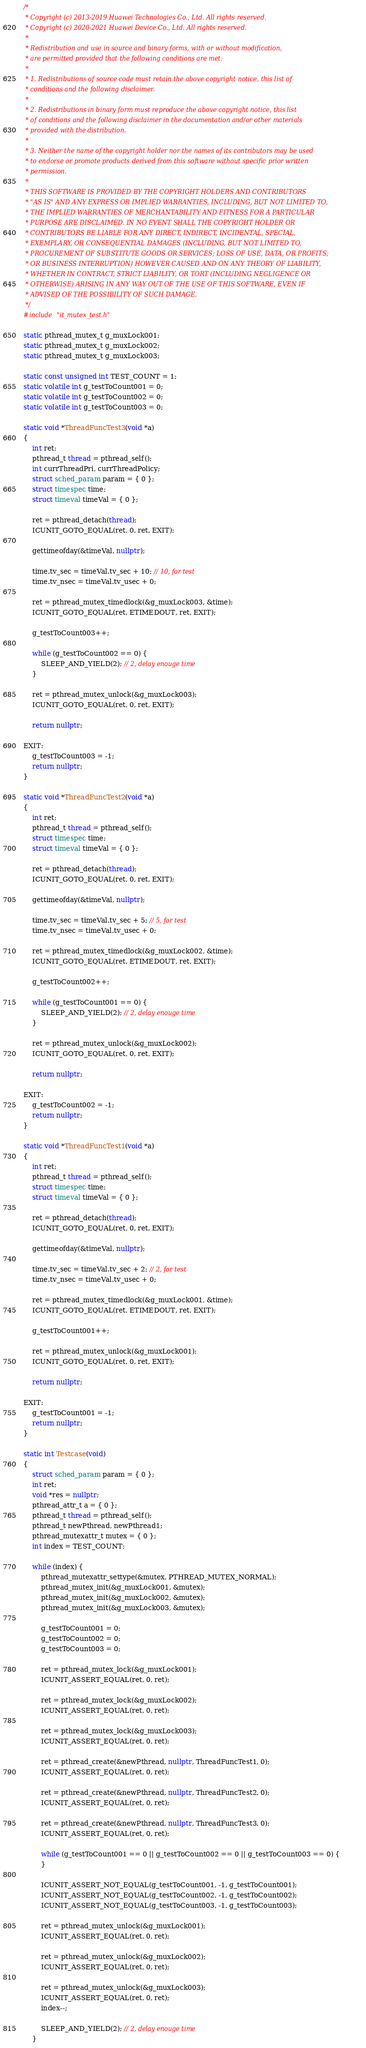Convert code to text. <code><loc_0><loc_0><loc_500><loc_500><_C++_>/*
 * Copyright (c) 2013-2019 Huawei Technologies Co., Ltd. All rights reserved.
 * Copyright (c) 2020-2021 Huawei Device Co., Ltd. All rights reserved.
 *
 * Redistribution and use in source and binary forms, with or without modification,
 * are permitted provided that the following conditions are met:
 *
 * 1. Redistributions of source code must retain the above copyright notice, this list of
 * conditions and the following disclaimer.
 *
 * 2. Redistributions in binary form must reproduce the above copyright notice, this list
 * of conditions and the following disclaimer in the documentation and/or other materials
 * provided with the distribution.
 *
 * 3. Neither the name of the copyright holder nor the names of its contributors may be used
 * to endorse or promote products derived from this software without specific prior written
 * permission.
 *
 * THIS SOFTWARE IS PROVIDED BY THE COPYRIGHT HOLDERS AND CONTRIBUTORS
 * "AS IS" AND ANY EXPRESS OR IMPLIED WARRANTIES, INCLUDING, BUT NOT LIMITED TO,
 * THE IMPLIED WARRANTIES OF MERCHANTABILITY AND FITNESS FOR A PARTICULAR
 * PURPOSE ARE DISCLAIMED. IN NO EVENT SHALL THE COPYRIGHT HOLDER OR
 * CONTRIBUTORS BE LIABLE FOR ANY DIRECT, INDIRECT, INCIDENTAL, SPECIAL,
 * EXEMPLARY, OR CONSEQUENTIAL DAMAGES (INCLUDING, BUT NOT LIMITED TO,
 * PROCUREMENT OF SUBSTITUTE GOODS OR SERVICES; LOSS OF USE, DATA, OR PROFITS;
 * OR BUSINESS INTERRUPTION) HOWEVER CAUSED AND ON ANY THEORY OF LIABILITY,
 * WHETHER IN CONTRACT, STRICT LIABILITY, OR TORT (INCLUDING NEGLIGENCE OR
 * OTHERWISE) ARISING IN ANY WAY OUT OF THE USE OF THIS SOFTWARE, EVEN IF
 * ADVISED OF THE POSSIBILITY OF SUCH DAMAGE.
 */
#include "it_mutex_test.h"

static pthread_mutex_t g_muxLock001;
static pthread_mutex_t g_muxLock002;
static pthread_mutex_t g_muxLock003;

static const unsigned int TEST_COUNT = 1;
static volatile int g_testToCount001 = 0;
static volatile int g_testToCount002 = 0;
static volatile int g_testToCount003 = 0;

static void *ThreadFuncTest3(void *a)
{
    int ret;
    pthread_t thread = pthread_self();
    int currThreadPri, currThreadPolicy;
    struct sched_param param = { 0 };
    struct timespec time;
    struct timeval timeVal = { 0 };

    ret = pthread_detach(thread);
    ICUNIT_GOTO_EQUAL(ret, 0, ret, EXIT);

    gettimeofday(&timeVal, nullptr);

    time.tv_sec = timeVal.tv_sec + 10; // 10, for test
    time.tv_nsec = timeVal.tv_usec + 0;

    ret = pthread_mutex_timedlock(&g_muxLock003, &time);
    ICUNIT_GOTO_EQUAL(ret, ETIMEDOUT, ret, EXIT);

    g_testToCount003++;

    while (g_testToCount002 == 0) {
        SLEEP_AND_YIELD(2); // 2, delay enouge time
    }

    ret = pthread_mutex_unlock(&g_muxLock003);
    ICUNIT_GOTO_EQUAL(ret, 0, ret, EXIT);

    return nullptr;

EXIT:
    g_testToCount003 = -1;
    return nullptr;
}

static void *ThreadFuncTest2(void *a)
{
    int ret;
    pthread_t thread = pthread_self();
    struct timespec time;
    struct timeval timeVal = { 0 };

    ret = pthread_detach(thread);
    ICUNIT_GOTO_EQUAL(ret, 0, ret, EXIT);

    gettimeofday(&timeVal, nullptr);

    time.tv_sec = timeVal.tv_sec + 5; // 5, for test
    time.tv_nsec = timeVal.tv_usec + 0;

    ret = pthread_mutex_timedlock(&g_muxLock002, &time);
    ICUNIT_GOTO_EQUAL(ret, ETIMEDOUT, ret, EXIT);

    g_testToCount002++;

    while (g_testToCount001 == 0) {
        SLEEP_AND_YIELD(2); // 2, delay enouge time
    }

    ret = pthread_mutex_unlock(&g_muxLock002);
    ICUNIT_GOTO_EQUAL(ret, 0, ret, EXIT);

    return nullptr;

EXIT:
    g_testToCount002 = -1;
    return nullptr;
}

static void *ThreadFuncTest1(void *a)
{
    int ret;
    pthread_t thread = pthread_self();
    struct timespec time;
    struct timeval timeVal = { 0 };

    ret = pthread_detach(thread);
    ICUNIT_GOTO_EQUAL(ret, 0, ret, EXIT);

    gettimeofday(&timeVal, nullptr);

    time.tv_sec = timeVal.tv_sec + 2; // 2, for test
    time.tv_nsec = timeVal.tv_usec + 0;

    ret = pthread_mutex_timedlock(&g_muxLock001, &time);
    ICUNIT_GOTO_EQUAL(ret, ETIMEDOUT, ret, EXIT);

    g_testToCount001++;

    ret = pthread_mutex_unlock(&g_muxLock001);
    ICUNIT_GOTO_EQUAL(ret, 0, ret, EXIT);

    return nullptr;

EXIT:
    g_testToCount001 = -1;
    return nullptr;
}

static int Testcase(void)
{
    struct sched_param param = { 0 };
    int ret;
    void *res = nullptr;
    pthread_attr_t a = { 0 };
    pthread_t thread = pthread_self();
    pthread_t newPthread, newPthread1;
    pthread_mutexattr_t mutex = { 0 };
    int index = TEST_COUNT;

    while (index) {
        pthread_mutexattr_settype(&mutex, PTHREAD_MUTEX_NORMAL);
        pthread_mutex_init(&g_muxLock001, &mutex);
        pthread_mutex_init(&g_muxLock002, &mutex);
        pthread_mutex_init(&g_muxLock003, &mutex);

        g_testToCount001 = 0;
        g_testToCount002 = 0;
        g_testToCount003 = 0;

        ret = pthread_mutex_lock(&g_muxLock001);
        ICUNIT_ASSERT_EQUAL(ret, 0, ret);

        ret = pthread_mutex_lock(&g_muxLock002);
        ICUNIT_ASSERT_EQUAL(ret, 0, ret);

        ret = pthread_mutex_lock(&g_muxLock003);
        ICUNIT_ASSERT_EQUAL(ret, 0, ret);

        ret = pthread_create(&newPthread, nullptr, ThreadFuncTest1, 0);
        ICUNIT_ASSERT_EQUAL(ret, 0, ret);

        ret = pthread_create(&newPthread, nullptr, ThreadFuncTest2, 0);
        ICUNIT_ASSERT_EQUAL(ret, 0, ret);

        ret = pthread_create(&newPthread, nullptr, ThreadFuncTest3, 0);
        ICUNIT_ASSERT_EQUAL(ret, 0, ret);

        while (g_testToCount001 == 0 || g_testToCount002 == 0 || g_testToCount003 == 0) {
        }

        ICUNIT_ASSERT_NOT_EQUAL(g_testToCount001, -1, g_testToCount001);
        ICUNIT_ASSERT_NOT_EQUAL(g_testToCount002, -1, g_testToCount002);
        ICUNIT_ASSERT_NOT_EQUAL(g_testToCount003, -1, g_testToCount003);

        ret = pthread_mutex_unlock(&g_muxLock001);
        ICUNIT_ASSERT_EQUAL(ret, 0, ret);

        ret = pthread_mutex_unlock(&g_muxLock002);
        ICUNIT_ASSERT_EQUAL(ret, 0, ret);

        ret = pthread_mutex_unlock(&g_muxLock003);
        ICUNIT_ASSERT_EQUAL(ret, 0, ret);
        index--;

        SLEEP_AND_YIELD(2); // 2, delay enouge time
    }
</code> 